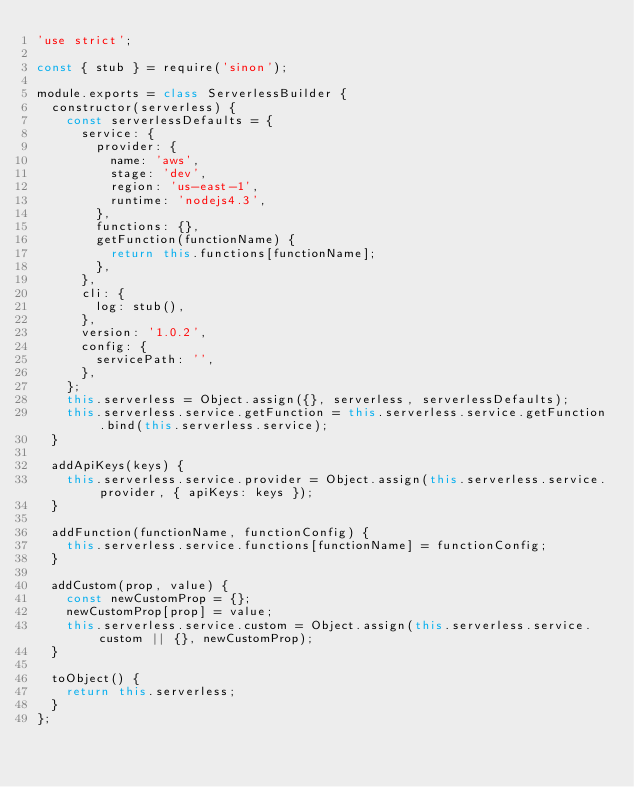Convert code to text. <code><loc_0><loc_0><loc_500><loc_500><_JavaScript_>'use strict';

const { stub } = require('sinon');

module.exports = class ServerlessBuilder {
  constructor(serverless) {
    const serverlessDefaults = {
      service: {
        provider: {
          name: 'aws',
          stage: 'dev',
          region: 'us-east-1',
          runtime: 'nodejs4.3',
        },
        functions: {},
        getFunction(functionName) {
          return this.functions[functionName];
        },
      },
      cli: {
        log: stub(),
      },
      version: '1.0.2',
      config: {
        servicePath: '',
      },
    };
    this.serverless = Object.assign({}, serverless, serverlessDefaults);
    this.serverless.service.getFunction = this.serverless.service.getFunction.bind(this.serverless.service);
  }

  addApiKeys(keys) {
    this.serverless.service.provider = Object.assign(this.serverless.service.provider, { apiKeys: keys });
  }

  addFunction(functionName, functionConfig) {
    this.serverless.service.functions[functionName] = functionConfig;
  }

  addCustom(prop, value) {
    const newCustomProp = {};
    newCustomProp[prop] = value;
    this.serverless.service.custom = Object.assign(this.serverless.service.custom || {}, newCustomProp);
  }

  toObject() {
    return this.serverless;
  }
};
</code> 